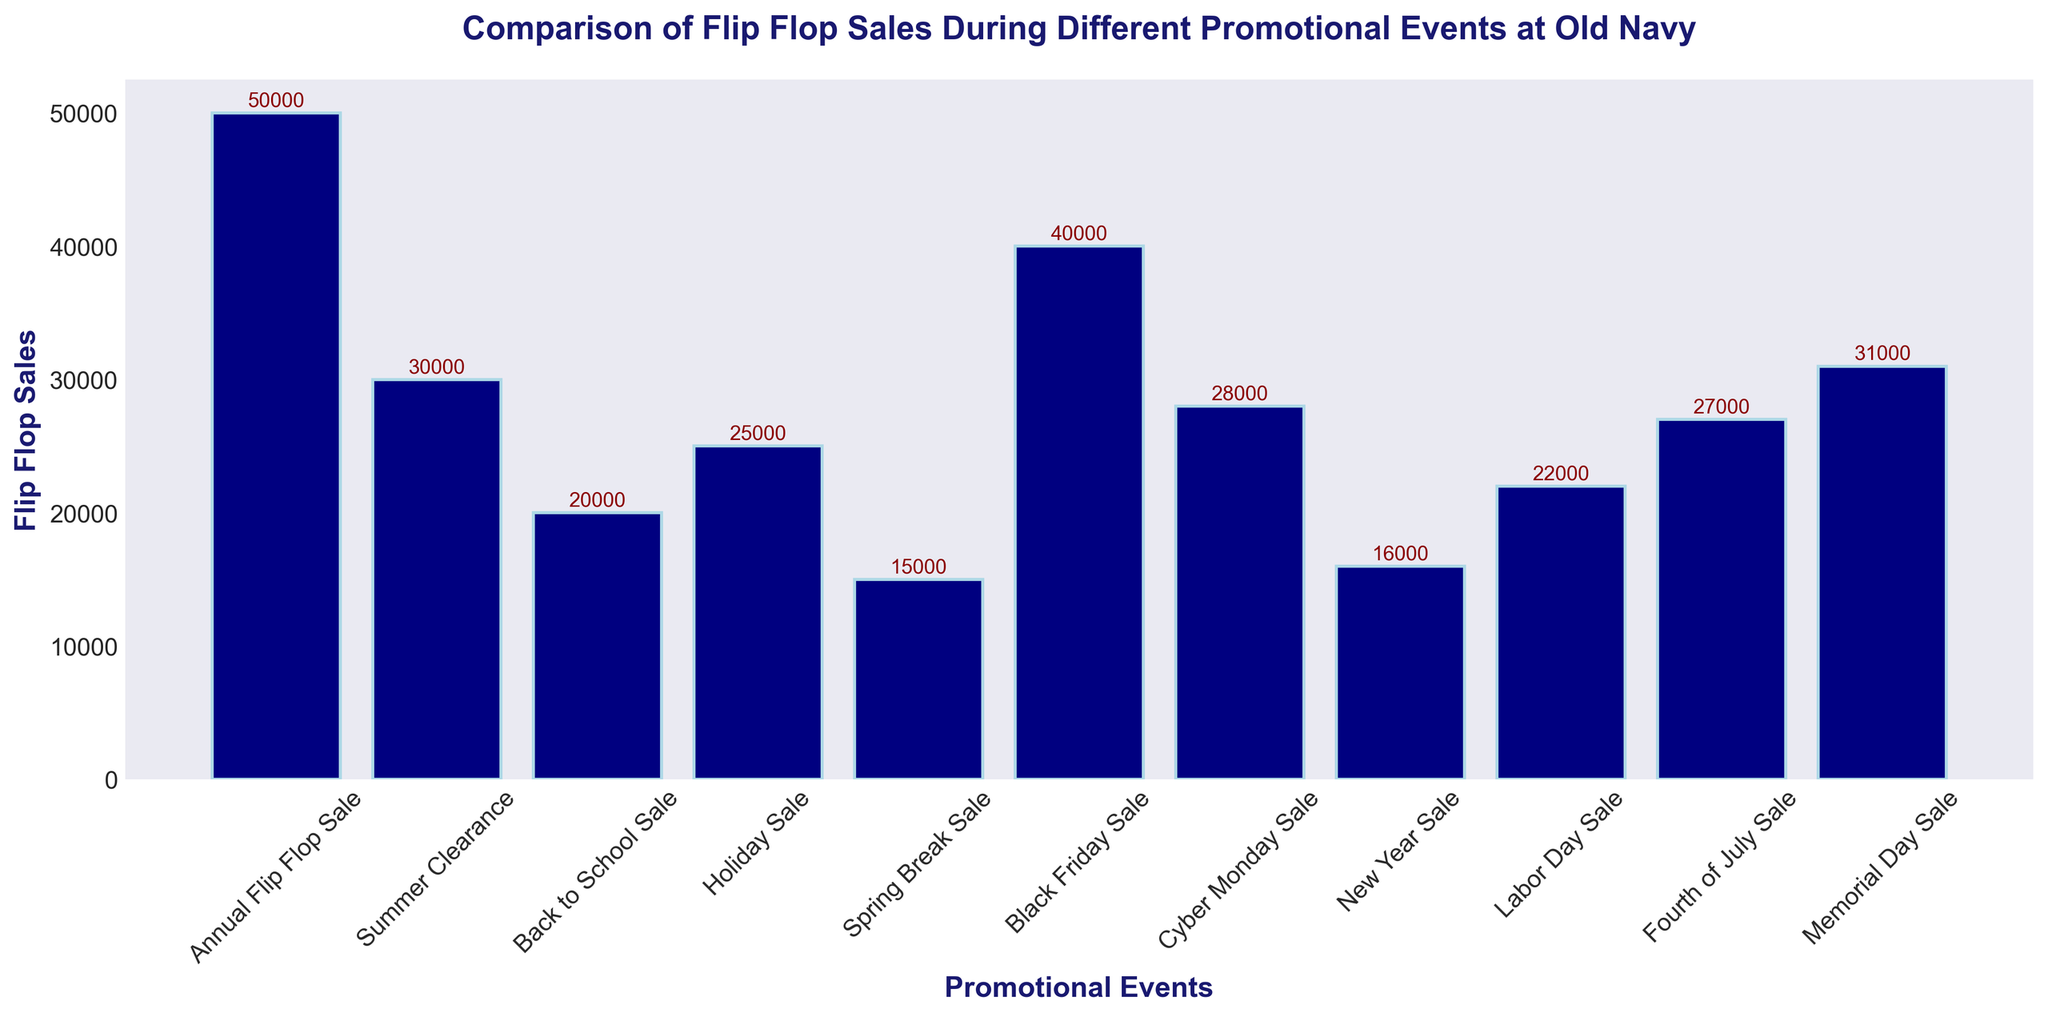Which event has the highest flip flop sales? Identify the bar that reaches the highest point on the y-axis. The "Annual Flip Flop Sale" bar is the tallest.
Answer: Annual Flip Flop Sale How many more flip flops were sold during the Black Friday Sale compared to the Spring Break Sale? Subtract the number of flip flops sold during the Spring Break Sale from those sold during the Black Friday Sale: 40000 - 15000 = 25000
Answer: 25000 What is the total number of flip flops sold during the Summer Clearance Sale and the Cyber Monday Sale combined? Add the number of flip flops sold during the Summer Clearance Sale and Cyber Monday Sale: 30000 + 28000 = 58000
Answer: 58000 Which event has the second lowest flip flop sales? Identify the event with the lowest bar after "Spring Break Sale". The second lowest bar is "New Year Sale" with 16000.
Answer: New Year Sale By how much do the flip flop sales for the Fourth of July Sale exceed those of the Back to School Sale? Subtract the number of flip flops sold during the Back to School Sale from those sold during the Fourth of July Sale: 27000 - 20000 = 7000
Answer: 7000 What is the median number of flip flop sales across all events? First, sort the sales numbers: [15000, 16000, 20000, 22000, 25000, 27000, 28000, 30000, 31000, 40000, 50000]. The median is the middle value: 27000
Answer: 27000 Which promotional event has fewer than 20000 flip flop sales? Identify the bars that have heights corresponding to less than 20000. The "Spring Break Sale" with 15000 and "New Year Sale" with 16000 are the ones.
Answer: Spring Break Sale, New Year Sale During which promotional event were exactly 40000 flip flop sales achieved? Identify the bar that indicates a height of 40000. The "Black Friday Sale" bar shows this value.
Answer: Black Friday Sale What is the difference in flip flop sales between the Holiday Sale and the Memorial Day Sale? Subtract the number of flip flops sold during the Holiday Sale from those sold during the Memorial Day Sale: 31000 - 25000 = 6000
Answer: 6000 